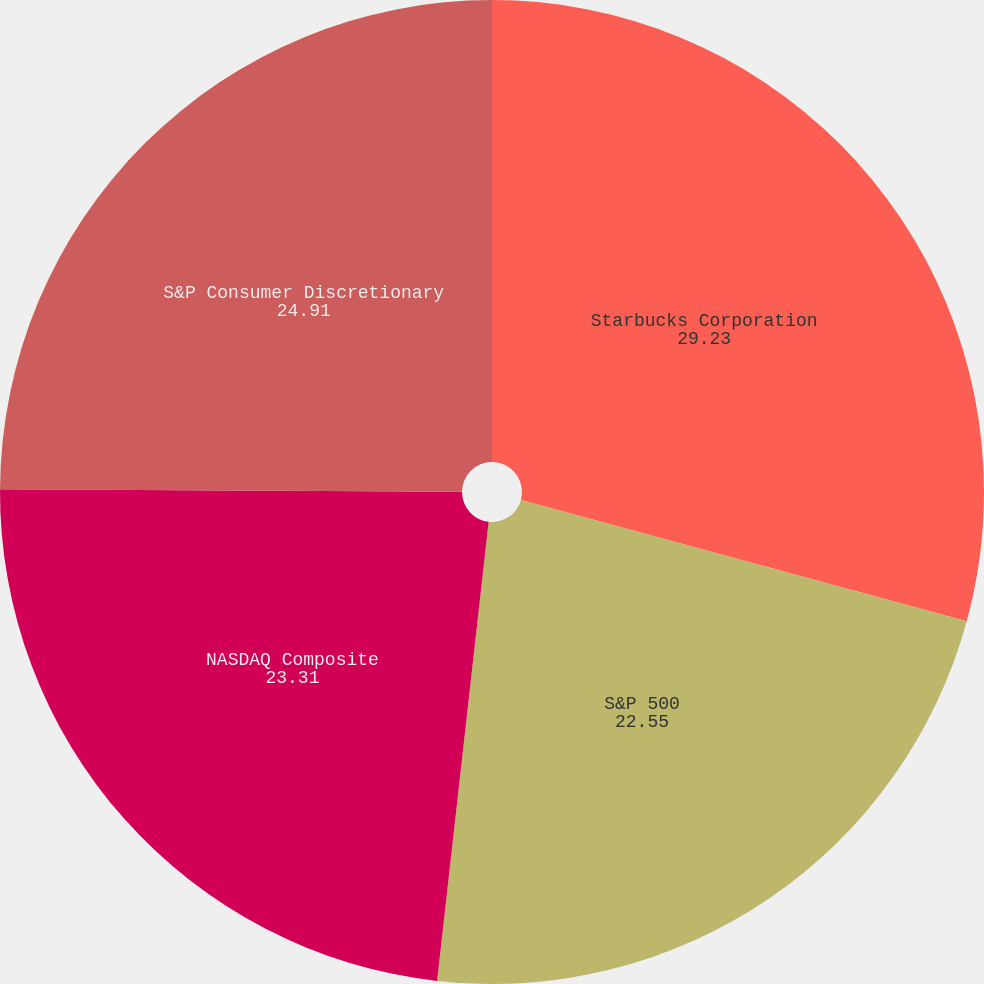Convert chart to OTSL. <chart><loc_0><loc_0><loc_500><loc_500><pie_chart><fcel>Starbucks Corporation<fcel>S&P 500<fcel>NASDAQ Composite<fcel>S&P Consumer Discretionary<nl><fcel>29.23%<fcel>22.55%<fcel>23.31%<fcel>24.91%<nl></chart> 